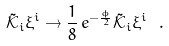Convert formula to latex. <formula><loc_0><loc_0><loc_500><loc_500>\tilde { \mathcal { K } } _ { i } \xi ^ { i } \to \frac { 1 } { 8 } \, e ^ { - \frac { \phi } { 2 } } \tilde { \mathcal { K } } _ { i } \xi ^ { i } \ .</formula> 